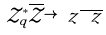<formula> <loc_0><loc_0><loc_500><loc_500>\mathcal { Z } ^ { * } _ { q } \overline { \mathcal { Z } } \rightarrow \ z \overline { \ z }</formula> 